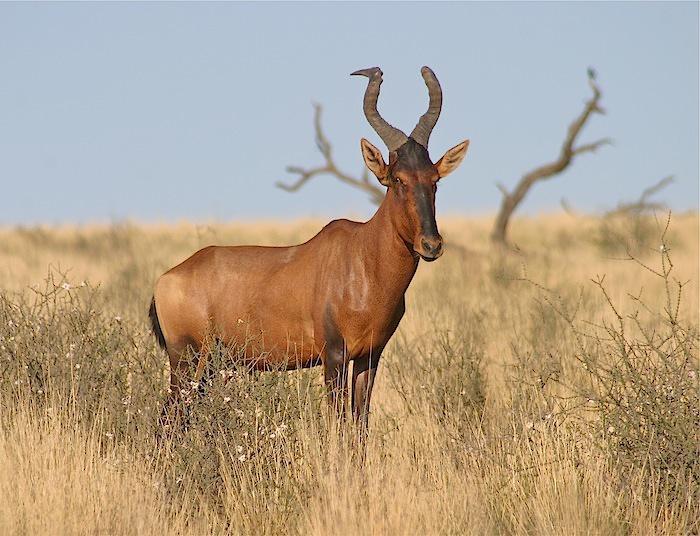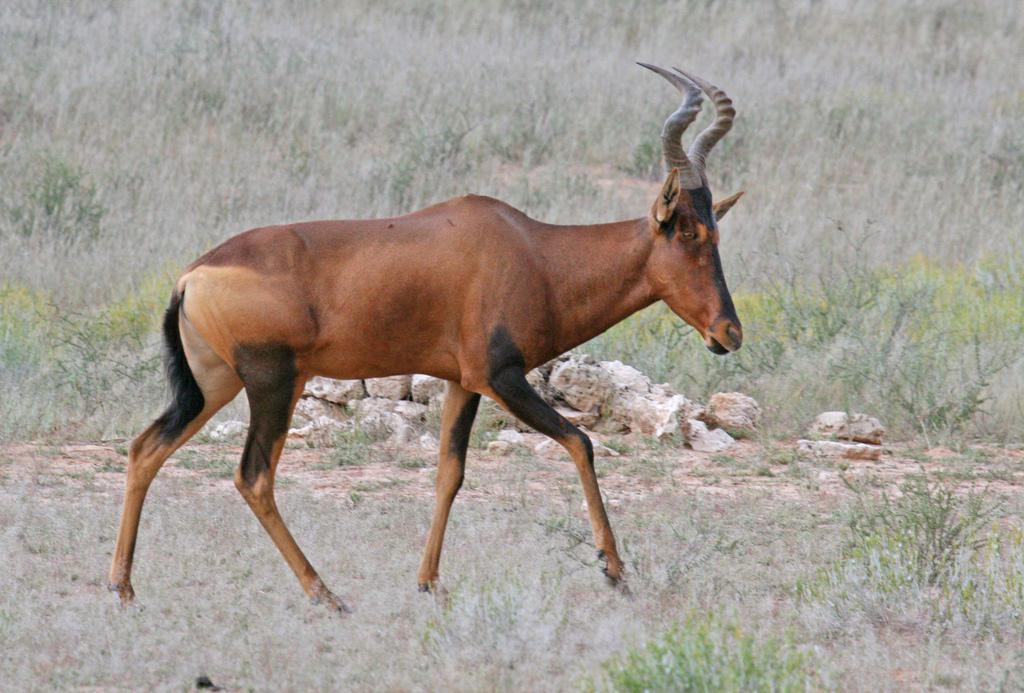The first image is the image on the left, the second image is the image on the right. Assess this claim about the two images: "There are more than two standing animals.". Correct or not? Answer yes or no. No. The first image is the image on the left, the second image is the image on the right. Analyze the images presented: Is the assertion "No photo contains more than one animal." valid? Answer yes or no. Yes. 